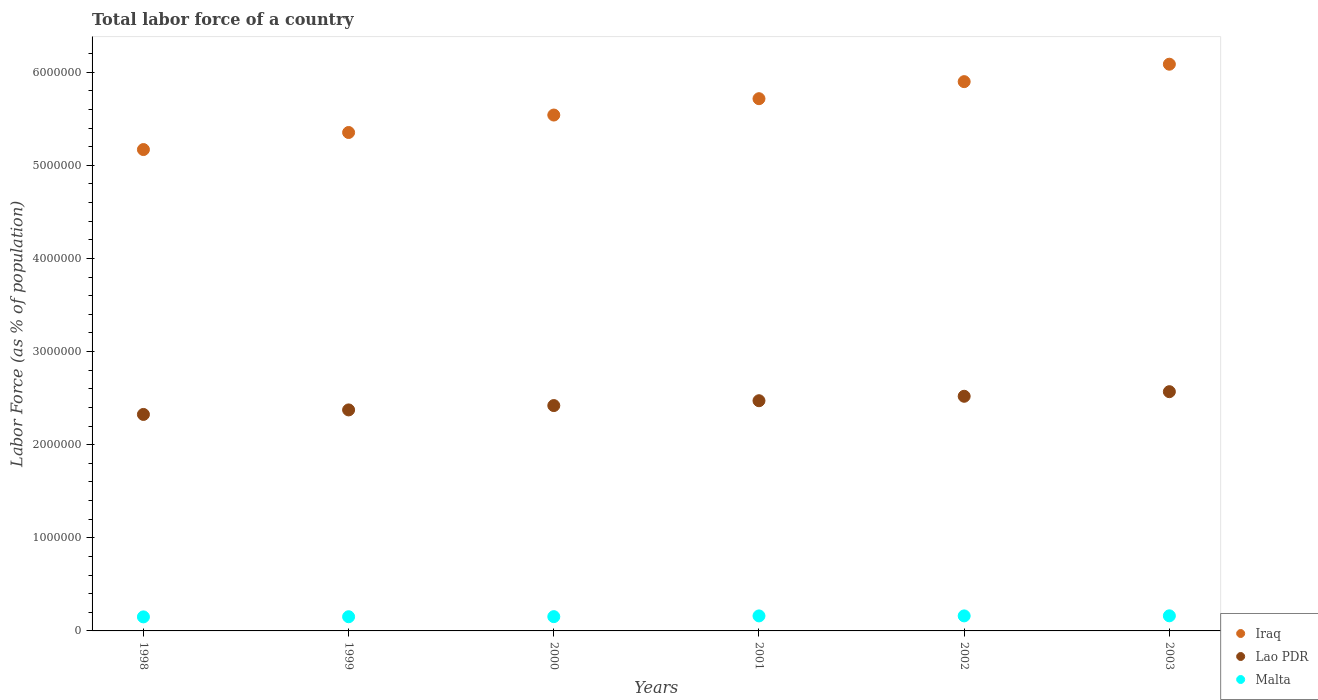Is the number of dotlines equal to the number of legend labels?
Your answer should be very brief. Yes. What is the percentage of labor force in Iraq in 2003?
Your answer should be very brief. 6.09e+06. Across all years, what is the maximum percentage of labor force in Lao PDR?
Provide a short and direct response. 2.57e+06. Across all years, what is the minimum percentage of labor force in Lao PDR?
Ensure brevity in your answer.  2.32e+06. What is the total percentage of labor force in Malta in the graph?
Offer a very short reply. 9.41e+05. What is the difference between the percentage of labor force in Lao PDR in 2000 and that in 2001?
Provide a succinct answer. -5.21e+04. What is the difference between the percentage of labor force in Iraq in 1999 and the percentage of labor force in Malta in 2000?
Make the answer very short. 5.20e+06. What is the average percentage of labor force in Lao PDR per year?
Your answer should be compact. 2.45e+06. In the year 2001, what is the difference between the percentage of labor force in Malta and percentage of labor force in Iraq?
Your answer should be very brief. -5.55e+06. What is the ratio of the percentage of labor force in Iraq in 1999 to that in 2000?
Ensure brevity in your answer.  0.97. What is the difference between the highest and the second highest percentage of labor force in Iraq?
Give a very brief answer. 1.87e+05. What is the difference between the highest and the lowest percentage of labor force in Lao PDR?
Offer a very short reply. 2.44e+05. Is the sum of the percentage of labor force in Lao PDR in 2002 and 2003 greater than the maximum percentage of labor force in Malta across all years?
Your response must be concise. Yes. Is the percentage of labor force in Lao PDR strictly greater than the percentage of labor force in Malta over the years?
Your response must be concise. Yes. Is the percentage of labor force in Iraq strictly less than the percentage of labor force in Malta over the years?
Make the answer very short. No. How many dotlines are there?
Give a very brief answer. 3. How many years are there in the graph?
Make the answer very short. 6. What is the difference between two consecutive major ticks on the Y-axis?
Offer a terse response. 1.00e+06. Does the graph contain any zero values?
Your response must be concise. No. Where does the legend appear in the graph?
Your answer should be very brief. Bottom right. What is the title of the graph?
Provide a short and direct response. Total labor force of a country. What is the label or title of the Y-axis?
Offer a terse response. Labor Force (as % of population). What is the Labor Force (as % of population) in Iraq in 1998?
Make the answer very short. 5.17e+06. What is the Labor Force (as % of population) in Lao PDR in 1998?
Your answer should be very brief. 2.32e+06. What is the Labor Force (as % of population) in Malta in 1998?
Provide a short and direct response. 1.51e+05. What is the Labor Force (as % of population) of Iraq in 1999?
Offer a very short reply. 5.35e+06. What is the Labor Force (as % of population) of Lao PDR in 1999?
Keep it short and to the point. 2.37e+06. What is the Labor Force (as % of population) in Malta in 1999?
Offer a terse response. 1.52e+05. What is the Labor Force (as % of population) of Iraq in 2000?
Provide a succinct answer. 5.54e+06. What is the Labor Force (as % of population) of Lao PDR in 2000?
Your answer should be very brief. 2.42e+06. What is the Labor Force (as % of population) in Malta in 2000?
Offer a very short reply. 1.53e+05. What is the Labor Force (as % of population) of Iraq in 2001?
Your response must be concise. 5.72e+06. What is the Labor Force (as % of population) in Lao PDR in 2001?
Your answer should be compact. 2.47e+06. What is the Labor Force (as % of population) in Malta in 2001?
Make the answer very short. 1.61e+05. What is the Labor Force (as % of population) in Iraq in 2002?
Provide a succinct answer. 5.90e+06. What is the Labor Force (as % of population) in Lao PDR in 2002?
Offer a terse response. 2.52e+06. What is the Labor Force (as % of population) in Malta in 2002?
Give a very brief answer. 1.61e+05. What is the Labor Force (as % of population) of Iraq in 2003?
Give a very brief answer. 6.09e+06. What is the Labor Force (as % of population) of Lao PDR in 2003?
Provide a succinct answer. 2.57e+06. What is the Labor Force (as % of population) in Malta in 2003?
Your answer should be very brief. 1.62e+05. Across all years, what is the maximum Labor Force (as % of population) in Iraq?
Offer a terse response. 6.09e+06. Across all years, what is the maximum Labor Force (as % of population) in Lao PDR?
Provide a short and direct response. 2.57e+06. Across all years, what is the maximum Labor Force (as % of population) of Malta?
Your answer should be compact. 1.62e+05. Across all years, what is the minimum Labor Force (as % of population) in Iraq?
Your answer should be compact. 5.17e+06. Across all years, what is the minimum Labor Force (as % of population) in Lao PDR?
Your response must be concise. 2.32e+06. Across all years, what is the minimum Labor Force (as % of population) in Malta?
Make the answer very short. 1.51e+05. What is the total Labor Force (as % of population) of Iraq in the graph?
Your response must be concise. 3.38e+07. What is the total Labor Force (as % of population) in Lao PDR in the graph?
Your answer should be very brief. 1.47e+07. What is the total Labor Force (as % of population) in Malta in the graph?
Keep it short and to the point. 9.41e+05. What is the difference between the Labor Force (as % of population) of Iraq in 1998 and that in 1999?
Offer a terse response. -1.83e+05. What is the difference between the Labor Force (as % of population) of Lao PDR in 1998 and that in 1999?
Your answer should be very brief. -4.86e+04. What is the difference between the Labor Force (as % of population) in Malta in 1998 and that in 1999?
Provide a succinct answer. -1601. What is the difference between the Labor Force (as % of population) of Iraq in 1998 and that in 2000?
Offer a terse response. -3.71e+05. What is the difference between the Labor Force (as % of population) of Lao PDR in 1998 and that in 2000?
Your response must be concise. -9.52e+04. What is the difference between the Labor Force (as % of population) of Malta in 1998 and that in 2000?
Your answer should be compact. -2578. What is the difference between the Labor Force (as % of population) in Iraq in 1998 and that in 2001?
Offer a very short reply. -5.46e+05. What is the difference between the Labor Force (as % of population) in Lao PDR in 1998 and that in 2001?
Offer a very short reply. -1.47e+05. What is the difference between the Labor Force (as % of population) in Malta in 1998 and that in 2001?
Give a very brief answer. -1.05e+04. What is the difference between the Labor Force (as % of population) in Iraq in 1998 and that in 2002?
Keep it short and to the point. -7.29e+05. What is the difference between the Labor Force (as % of population) of Lao PDR in 1998 and that in 2002?
Give a very brief answer. -1.95e+05. What is the difference between the Labor Force (as % of population) of Malta in 1998 and that in 2002?
Keep it short and to the point. -1.07e+04. What is the difference between the Labor Force (as % of population) in Iraq in 1998 and that in 2003?
Provide a succinct answer. -9.17e+05. What is the difference between the Labor Force (as % of population) of Lao PDR in 1998 and that in 2003?
Provide a succinct answer. -2.44e+05. What is the difference between the Labor Force (as % of population) in Malta in 1998 and that in 2003?
Ensure brevity in your answer.  -1.15e+04. What is the difference between the Labor Force (as % of population) of Iraq in 1999 and that in 2000?
Offer a very short reply. -1.87e+05. What is the difference between the Labor Force (as % of population) in Lao PDR in 1999 and that in 2000?
Provide a short and direct response. -4.66e+04. What is the difference between the Labor Force (as % of population) in Malta in 1999 and that in 2000?
Your answer should be compact. -977. What is the difference between the Labor Force (as % of population) of Iraq in 1999 and that in 2001?
Provide a succinct answer. -3.63e+05. What is the difference between the Labor Force (as % of population) in Lao PDR in 1999 and that in 2001?
Make the answer very short. -9.86e+04. What is the difference between the Labor Force (as % of population) in Malta in 1999 and that in 2001?
Your response must be concise. -8874. What is the difference between the Labor Force (as % of population) in Iraq in 1999 and that in 2002?
Your answer should be compact. -5.46e+05. What is the difference between the Labor Force (as % of population) of Lao PDR in 1999 and that in 2002?
Make the answer very short. -1.46e+05. What is the difference between the Labor Force (as % of population) of Malta in 1999 and that in 2002?
Your answer should be very brief. -9082. What is the difference between the Labor Force (as % of population) of Iraq in 1999 and that in 2003?
Your answer should be very brief. -7.33e+05. What is the difference between the Labor Force (as % of population) of Lao PDR in 1999 and that in 2003?
Offer a very short reply. -1.96e+05. What is the difference between the Labor Force (as % of population) in Malta in 1999 and that in 2003?
Make the answer very short. -9860. What is the difference between the Labor Force (as % of population) in Iraq in 2000 and that in 2001?
Keep it short and to the point. -1.76e+05. What is the difference between the Labor Force (as % of population) in Lao PDR in 2000 and that in 2001?
Provide a succinct answer. -5.21e+04. What is the difference between the Labor Force (as % of population) in Malta in 2000 and that in 2001?
Provide a short and direct response. -7897. What is the difference between the Labor Force (as % of population) in Iraq in 2000 and that in 2002?
Offer a terse response. -3.59e+05. What is the difference between the Labor Force (as % of population) of Lao PDR in 2000 and that in 2002?
Keep it short and to the point. -9.99e+04. What is the difference between the Labor Force (as % of population) of Malta in 2000 and that in 2002?
Your answer should be compact. -8105. What is the difference between the Labor Force (as % of population) of Iraq in 2000 and that in 2003?
Give a very brief answer. -5.46e+05. What is the difference between the Labor Force (as % of population) of Lao PDR in 2000 and that in 2003?
Offer a terse response. -1.49e+05. What is the difference between the Labor Force (as % of population) of Malta in 2000 and that in 2003?
Your response must be concise. -8883. What is the difference between the Labor Force (as % of population) in Iraq in 2001 and that in 2002?
Make the answer very short. -1.83e+05. What is the difference between the Labor Force (as % of population) in Lao PDR in 2001 and that in 2002?
Give a very brief answer. -4.78e+04. What is the difference between the Labor Force (as % of population) in Malta in 2001 and that in 2002?
Give a very brief answer. -208. What is the difference between the Labor Force (as % of population) in Iraq in 2001 and that in 2003?
Give a very brief answer. -3.70e+05. What is the difference between the Labor Force (as % of population) in Lao PDR in 2001 and that in 2003?
Provide a succinct answer. -9.72e+04. What is the difference between the Labor Force (as % of population) in Malta in 2001 and that in 2003?
Offer a very short reply. -986. What is the difference between the Labor Force (as % of population) in Iraq in 2002 and that in 2003?
Make the answer very short. -1.87e+05. What is the difference between the Labor Force (as % of population) in Lao PDR in 2002 and that in 2003?
Keep it short and to the point. -4.94e+04. What is the difference between the Labor Force (as % of population) in Malta in 2002 and that in 2003?
Your answer should be very brief. -778. What is the difference between the Labor Force (as % of population) of Iraq in 1998 and the Labor Force (as % of population) of Lao PDR in 1999?
Your response must be concise. 2.80e+06. What is the difference between the Labor Force (as % of population) in Iraq in 1998 and the Labor Force (as % of population) in Malta in 1999?
Make the answer very short. 5.02e+06. What is the difference between the Labor Force (as % of population) of Lao PDR in 1998 and the Labor Force (as % of population) of Malta in 1999?
Provide a succinct answer. 2.17e+06. What is the difference between the Labor Force (as % of population) in Iraq in 1998 and the Labor Force (as % of population) in Lao PDR in 2000?
Your answer should be compact. 2.75e+06. What is the difference between the Labor Force (as % of population) in Iraq in 1998 and the Labor Force (as % of population) in Malta in 2000?
Make the answer very short. 5.02e+06. What is the difference between the Labor Force (as % of population) in Lao PDR in 1998 and the Labor Force (as % of population) in Malta in 2000?
Provide a short and direct response. 2.17e+06. What is the difference between the Labor Force (as % of population) of Iraq in 1998 and the Labor Force (as % of population) of Lao PDR in 2001?
Ensure brevity in your answer.  2.70e+06. What is the difference between the Labor Force (as % of population) of Iraq in 1998 and the Labor Force (as % of population) of Malta in 2001?
Give a very brief answer. 5.01e+06. What is the difference between the Labor Force (as % of population) of Lao PDR in 1998 and the Labor Force (as % of population) of Malta in 2001?
Offer a terse response. 2.16e+06. What is the difference between the Labor Force (as % of population) of Iraq in 1998 and the Labor Force (as % of population) of Lao PDR in 2002?
Ensure brevity in your answer.  2.65e+06. What is the difference between the Labor Force (as % of population) of Iraq in 1998 and the Labor Force (as % of population) of Malta in 2002?
Ensure brevity in your answer.  5.01e+06. What is the difference between the Labor Force (as % of population) in Lao PDR in 1998 and the Labor Force (as % of population) in Malta in 2002?
Give a very brief answer. 2.16e+06. What is the difference between the Labor Force (as % of population) in Iraq in 1998 and the Labor Force (as % of population) in Lao PDR in 2003?
Make the answer very short. 2.60e+06. What is the difference between the Labor Force (as % of population) in Iraq in 1998 and the Labor Force (as % of population) in Malta in 2003?
Ensure brevity in your answer.  5.01e+06. What is the difference between the Labor Force (as % of population) of Lao PDR in 1998 and the Labor Force (as % of population) of Malta in 2003?
Your answer should be very brief. 2.16e+06. What is the difference between the Labor Force (as % of population) of Iraq in 1999 and the Labor Force (as % of population) of Lao PDR in 2000?
Offer a terse response. 2.93e+06. What is the difference between the Labor Force (as % of population) in Iraq in 1999 and the Labor Force (as % of population) in Malta in 2000?
Keep it short and to the point. 5.20e+06. What is the difference between the Labor Force (as % of population) in Lao PDR in 1999 and the Labor Force (as % of population) in Malta in 2000?
Offer a very short reply. 2.22e+06. What is the difference between the Labor Force (as % of population) of Iraq in 1999 and the Labor Force (as % of population) of Lao PDR in 2001?
Make the answer very short. 2.88e+06. What is the difference between the Labor Force (as % of population) in Iraq in 1999 and the Labor Force (as % of population) in Malta in 2001?
Your answer should be compact. 5.19e+06. What is the difference between the Labor Force (as % of population) in Lao PDR in 1999 and the Labor Force (as % of population) in Malta in 2001?
Provide a short and direct response. 2.21e+06. What is the difference between the Labor Force (as % of population) of Iraq in 1999 and the Labor Force (as % of population) of Lao PDR in 2002?
Offer a terse response. 2.83e+06. What is the difference between the Labor Force (as % of population) in Iraq in 1999 and the Labor Force (as % of population) in Malta in 2002?
Provide a succinct answer. 5.19e+06. What is the difference between the Labor Force (as % of population) in Lao PDR in 1999 and the Labor Force (as % of population) in Malta in 2002?
Provide a short and direct response. 2.21e+06. What is the difference between the Labor Force (as % of population) of Iraq in 1999 and the Labor Force (as % of population) of Lao PDR in 2003?
Your response must be concise. 2.78e+06. What is the difference between the Labor Force (as % of population) of Iraq in 1999 and the Labor Force (as % of population) of Malta in 2003?
Your answer should be compact. 5.19e+06. What is the difference between the Labor Force (as % of population) in Lao PDR in 1999 and the Labor Force (as % of population) in Malta in 2003?
Your answer should be compact. 2.21e+06. What is the difference between the Labor Force (as % of population) of Iraq in 2000 and the Labor Force (as % of population) of Lao PDR in 2001?
Your answer should be compact. 3.07e+06. What is the difference between the Labor Force (as % of population) in Iraq in 2000 and the Labor Force (as % of population) in Malta in 2001?
Ensure brevity in your answer.  5.38e+06. What is the difference between the Labor Force (as % of population) of Lao PDR in 2000 and the Labor Force (as % of population) of Malta in 2001?
Keep it short and to the point. 2.26e+06. What is the difference between the Labor Force (as % of population) in Iraq in 2000 and the Labor Force (as % of population) in Lao PDR in 2002?
Provide a succinct answer. 3.02e+06. What is the difference between the Labor Force (as % of population) of Iraq in 2000 and the Labor Force (as % of population) of Malta in 2002?
Provide a succinct answer. 5.38e+06. What is the difference between the Labor Force (as % of population) of Lao PDR in 2000 and the Labor Force (as % of population) of Malta in 2002?
Ensure brevity in your answer.  2.26e+06. What is the difference between the Labor Force (as % of population) of Iraq in 2000 and the Labor Force (as % of population) of Lao PDR in 2003?
Provide a succinct answer. 2.97e+06. What is the difference between the Labor Force (as % of population) of Iraq in 2000 and the Labor Force (as % of population) of Malta in 2003?
Ensure brevity in your answer.  5.38e+06. What is the difference between the Labor Force (as % of population) in Lao PDR in 2000 and the Labor Force (as % of population) in Malta in 2003?
Offer a terse response. 2.26e+06. What is the difference between the Labor Force (as % of population) in Iraq in 2001 and the Labor Force (as % of population) in Lao PDR in 2002?
Make the answer very short. 3.20e+06. What is the difference between the Labor Force (as % of population) in Iraq in 2001 and the Labor Force (as % of population) in Malta in 2002?
Ensure brevity in your answer.  5.55e+06. What is the difference between the Labor Force (as % of population) in Lao PDR in 2001 and the Labor Force (as % of population) in Malta in 2002?
Offer a terse response. 2.31e+06. What is the difference between the Labor Force (as % of population) of Iraq in 2001 and the Labor Force (as % of population) of Lao PDR in 2003?
Your answer should be very brief. 3.15e+06. What is the difference between the Labor Force (as % of population) in Iraq in 2001 and the Labor Force (as % of population) in Malta in 2003?
Offer a terse response. 5.55e+06. What is the difference between the Labor Force (as % of population) of Lao PDR in 2001 and the Labor Force (as % of population) of Malta in 2003?
Offer a very short reply. 2.31e+06. What is the difference between the Labor Force (as % of population) of Iraq in 2002 and the Labor Force (as % of population) of Lao PDR in 2003?
Keep it short and to the point. 3.33e+06. What is the difference between the Labor Force (as % of population) of Iraq in 2002 and the Labor Force (as % of population) of Malta in 2003?
Give a very brief answer. 5.74e+06. What is the difference between the Labor Force (as % of population) in Lao PDR in 2002 and the Labor Force (as % of population) in Malta in 2003?
Make the answer very short. 2.36e+06. What is the average Labor Force (as % of population) in Iraq per year?
Your answer should be very brief. 5.63e+06. What is the average Labor Force (as % of population) of Lao PDR per year?
Provide a succinct answer. 2.45e+06. What is the average Labor Force (as % of population) in Malta per year?
Ensure brevity in your answer.  1.57e+05. In the year 1998, what is the difference between the Labor Force (as % of population) in Iraq and Labor Force (as % of population) in Lao PDR?
Keep it short and to the point. 2.84e+06. In the year 1998, what is the difference between the Labor Force (as % of population) of Iraq and Labor Force (as % of population) of Malta?
Offer a very short reply. 5.02e+06. In the year 1998, what is the difference between the Labor Force (as % of population) of Lao PDR and Labor Force (as % of population) of Malta?
Offer a terse response. 2.17e+06. In the year 1999, what is the difference between the Labor Force (as % of population) of Iraq and Labor Force (as % of population) of Lao PDR?
Offer a very short reply. 2.98e+06. In the year 1999, what is the difference between the Labor Force (as % of population) of Iraq and Labor Force (as % of population) of Malta?
Provide a succinct answer. 5.20e+06. In the year 1999, what is the difference between the Labor Force (as % of population) of Lao PDR and Labor Force (as % of population) of Malta?
Your answer should be compact. 2.22e+06. In the year 2000, what is the difference between the Labor Force (as % of population) of Iraq and Labor Force (as % of population) of Lao PDR?
Offer a terse response. 3.12e+06. In the year 2000, what is the difference between the Labor Force (as % of population) in Iraq and Labor Force (as % of population) in Malta?
Your response must be concise. 5.39e+06. In the year 2000, what is the difference between the Labor Force (as % of population) of Lao PDR and Labor Force (as % of population) of Malta?
Offer a terse response. 2.27e+06. In the year 2001, what is the difference between the Labor Force (as % of population) in Iraq and Labor Force (as % of population) in Lao PDR?
Provide a succinct answer. 3.24e+06. In the year 2001, what is the difference between the Labor Force (as % of population) of Iraq and Labor Force (as % of population) of Malta?
Offer a very short reply. 5.55e+06. In the year 2001, what is the difference between the Labor Force (as % of population) in Lao PDR and Labor Force (as % of population) in Malta?
Provide a succinct answer. 2.31e+06. In the year 2002, what is the difference between the Labor Force (as % of population) of Iraq and Labor Force (as % of population) of Lao PDR?
Your response must be concise. 3.38e+06. In the year 2002, what is the difference between the Labor Force (as % of population) of Iraq and Labor Force (as % of population) of Malta?
Your answer should be compact. 5.74e+06. In the year 2002, what is the difference between the Labor Force (as % of population) of Lao PDR and Labor Force (as % of population) of Malta?
Ensure brevity in your answer.  2.36e+06. In the year 2003, what is the difference between the Labor Force (as % of population) in Iraq and Labor Force (as % of population) in Lao PDR?
Your answer should be compact. 3.52e+06. In the year 2003, what is the difference between the Labor Force (as % of population) in Iraq and Labor Force (as % of population) in Malta?
Your answer should be compact. 5.92e+06. In the year 2003, what is the difference between the Labor Force (as % of population) of Lao PDR and Labor Force (as % of population) of Malta?
Give a very brief answer. 2.41e+06. What is the ratio of the Labor Force (as % of population) in Iraq in 1998 to that in 1999?
Offer a terse response. 0.97. What is the ratio of the Labor Force (as % of population) in Lao PDR in 1998 to that in 1999?
Provide a short and direct response. 0.98. What is the ratio of the Labor Force (as % of population) of Malta in 1998 to that in 1999?
Give a very brief answer. 0.99. What is the ratio of the Labor Force (as % of population) in Iraq in 1998 to that in 2000?
Offer a very short reply. 0.93. What is the ratio of the Labor Force (as % of population) of Lao PDR in 1998 to that in 2000?
Make the answer very short. 0.96. What is the ratio of the Labor Force (as % of population) of Malta in 1998 to that in 2000?
Your response must be concise. 0.98. What is the ratio of the Labor Force (as % of population) of Iraq in 1998 to that in 2001?
Make the answer very short. 0.9. What is the ratio of the Labor Force (as % of population) of Lao PDR in 1998 to that in 2001?
Your response must be concise. 0.94. What is the ratio of the Labor Force (as % of population) in Malta in 1998 to that in 2001?
Give a very brief answer. 0.94. What is the ratio of the Labor Force (as % of population) of Iraq in 1998 to that in 2002?
Your response must be concise. 0.88. What is the ratio of the Labor Force (as % of population) of Lao PDR in 1998 to that in 2002?
Offer a terse response. 0.92. What is the ratio of the Labor Force (as % of population) in Malta in 1998 to that in 2002?
Your answer should be compact. 0.93. What is the ratio of the Labor Force (as % of population) in Iraq in 1998 to that in 2003?
Your answer should be compact. 0.85. What is the ratio of the Labor Force (as % of population) of Lao PDR in 1998 to that in 2003?
Your answer should be compact. 0.9. What is the ratio of the Labor Force (as % of population) in Malta in 1998 to that in 2003?
Keep it short and to the point. 0.93. What is the ratio of the Labor Force (as % of population) of Iraq in 1999 to that in 2000?
Keep it short and to the point. 0.97. What is the ratio of the Labor Force (as % of population) of Lao PDR in 1999 to that in 2000?
Your answer should be compact. 0.98. What is the ratio of the Labor Force (as % of population) of Iraq in 1999 to that in 2001?
Your response must be concise. 0.94. What is the ratio of the Labor Force (as % of population) of Lao PDR in 1999 to that in 2001?
Offer a very short reply. 0.96. What is the ratio of the Labor Force (as % of population) of Malta in 1999 to that in 2001?
Provide a succinct answer. 0.94. What is the ratio of the Labor Force (as % of population) of Iraq in 1999 to that in 2002?
Your response must be concise. 0.91. What is the ratio of the Labor Force (as % of population) in Lao PDR in 1999 to that in 2002?
Give a very brief answer. 0.94. What is the ratio of the Labor Force (as % of population) in Malta in 1999 to that in 2002?
Your answer should be compact. 0.94. What is the ratio of the Labor Force (as % of population) in Iraq in 1999 to that in 2003?
Provide a succinct answer. 0.88. What is the ratio of the Labor Force (as % of population) of Lao PDR in 1999 to that in 2003?
Make the answer very short. 0.92. What is the ratio of the Labor Force (as % of population) in Malta in 1999 to that in 2003?
Your answer should be very brief. 0.94. What is the ratio of the Labor Force (as % of population) in Iraq in 2000 to that in 2001?
Make the answer very short. 0.97. What is the ratio of the Labor Force (as % of population) of Lao PDR in 2000 to that in 2001?
Keep it short and to the point. 0.98. What is the ratio of the Labor Force (as % of population) of Malta in 2000 to that in 2001?
Keep it short and to the point. 0.95. What is the ratio of the Labor Force (as % of population) in Iraq in 2000 to that in 2002?
Provide a short and direct response. 0.94. What is the ratio of the Labor Force (as % of population) in Lao PDR in 2000 to that in 2002?
Ensure brevity in your answer.  0.96. What is the ratio of the Labor Force (as % of population) in Malta in 2000 to that in 2002?
Offer a terse response. 0.95. What is the ratio of the Labor Force (as % of population) of Iraq in 2000 to that in 2003?
Keep it short and to the point. 0.91. What is the ratio of the Labor Force (as % of population) of Lao PDR in 2000 to that in 2003?
Keep it short and to the point. 0.94. What is the ratio of the Labor Force (as % of population) of Malta in 2000 to that in 2003?
Provide a succinct answer. 0.95. What is the ratio of the Labor Force (as % of population) of Iraq in 2001 to that in 2002?
Your answer should be very brief. 0.97. What is the ratio of the Labor Force (as % of population) of Lao PDR in 2001 to that in 2002?
Keep it short and to the point. 0.98. What is the ratio of the Labor Force (as % of population) of Iraq in 2001 to that in 2003?
Offer a very short reply. 0.94. What is the ratio of the Labor Force (as % of population) in Lao PDR in 2001 to that in 2003?
Offer a very short reply. 0.96. What is the ratio of the Labor Force (as % of population) in Iraq in 2002 to that in 2003?
Your answer should be very brief. 0.97. What is the ratio of the Labor Force (as % of population) of Lao PDR in 2002 to that in 2003?
Make the answer very short. 0.98. What is the ratio of the Labor Force (as % of population) of Malta in 2002 to that in 2003?
Provide a short and direct response. 1. What is the difference between the highest and the second highest Labor Force (as % of population) of Iraq?
Your answer should be very brief. 1.87e+05. What is the difference between the highest and the second highest Labor Force (as % of population) in Lao PDR?
Your response must be concise. 4.94e+04. What is the difference between the highest and the second highest Labor Force (as % of population) of Malta?
Make the answer very short. 778. What is the difference between the highest and the lowest Labor Force (as % of population) of Iraq?
Offer a very short reply. 9.17e+05. What is the difference between the highest and the lowest Labor Force (as % of population) of Lao PDR?
Provide a succinct answer. 2.44e+05. What is the difference between the highest and the lowest Labor Force (as % of population) in Malta?
Provide a succinct answer. 1.15e+04. 